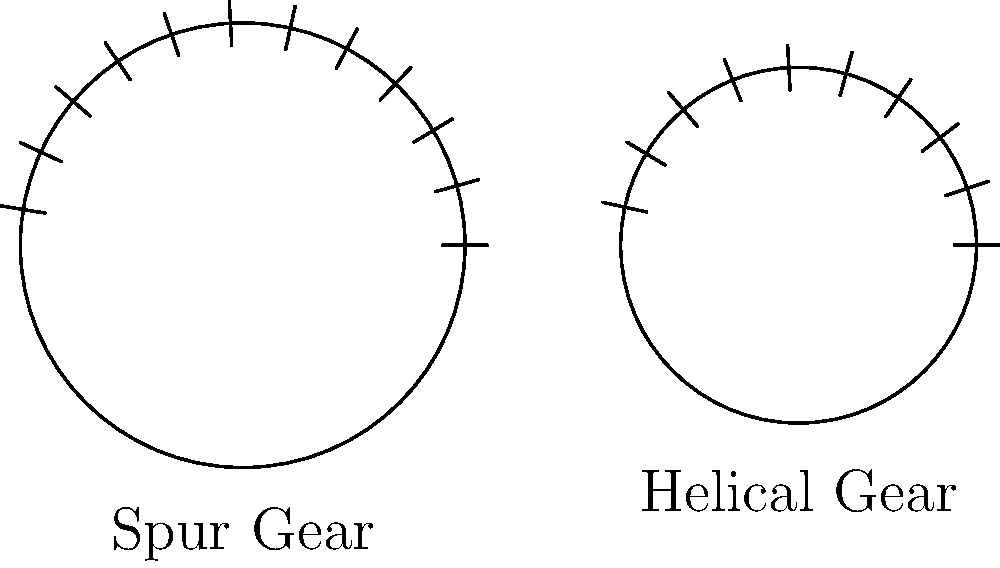Given your expertise in linguistics and natural language processing, consider how you might analyze the efficiency of different gear types in mechanical systems. The image shows two common gear profiles: a spur gear and a helical gear. Based on their tooth profiles and your understanding of force distribution in language structures, which gear type would you hypothesize to be more efficient in power transmission and why? To answer this question, let's approach it step-by-step, drawing parallels between linguistic structures and mechanical systems:

1. Tooth profile analysis:
   - Spur gear: Straight teeth parallel to the axis of rotation.
   - Helical gear: Teeth cut at an angle to the axis of rotation.

2. Force distribution:
   - In linguistics, we often analyze how meaning is distributed across different elements of a sentence.
   - Similarly, in gears, force is distributed across the teeth during power transmission.

3. Contact ratio:
   - Spur gears: Lower contact ratio, as fewer teeth are engaged simultaneously.
   - Helical gears: Higher contact ratio due to the angled teeth, allowing more teeth to be in contact.

4. Smoothness of operation:
   - In language, smoother transitions between phonemes often lead to more efficient communication.
   - For gears, smoother operation typically indicates higher efficiency.

5. Noise reduction:
   - Helical gears have a gradual engagement of teeth, reducing noise.
   - This is analogous to how certain phonetic transitions in language can reduce cognitive load.

6. Load distribution:
   - Helical gears distribute the load over a larger area due to their angled teeth.
   - This is similar to how complex ideas in language are often distributed across multiple clauses for better comprehension.

7. Efficiency in power transmission:
   - The gradual engagement and higher contact ratio of helical gears lead to more efficient power transmission.
   - This is comparable to how well-structured sentences with smooth transitions can more efficiently convey complex ideas.

Based on these factors, we can hypothesize that helical gears would be more efficient in power transmission due to their smoother operation, better load distribution, and higher contact ratio.
Answer: Helical gears are likely more efficient due to higher contact ratio and better load distribution. 